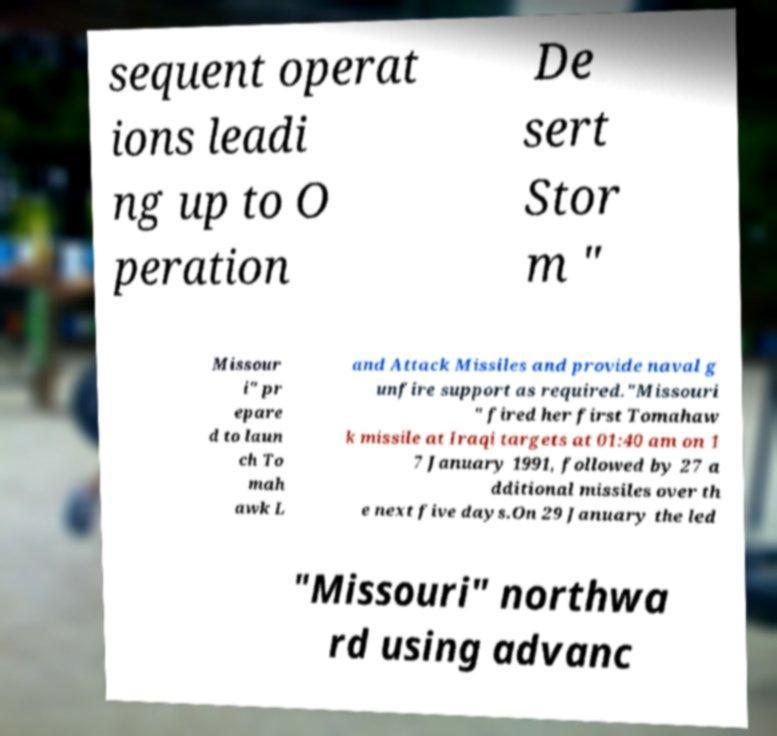For documentation purposes, I need the text within this image transcribed. Could you provide that? sequent operat ions leadi ng up to O peration De sert Stor m " Missour i" pr epare d to laun ch To mah awk L and Attack Missiles and provide naval g unfire support as required."Missouri " fired her first Tomahaw k missile at Iraqi targets at 01:40 am on 1 7 January 1991, followed by 27 a dditional missiles over th e next five days.On 29 January the led "Missouri" northwa rd using advanc 